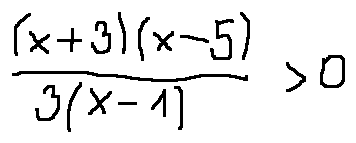Convert formula to latex. <formula><loc_0><loc_0><loc_500><loc_500>\frac { ( x + 3 ) ( x - 5 ) } { 3 ( x - 1 ) } > 0</formula> 